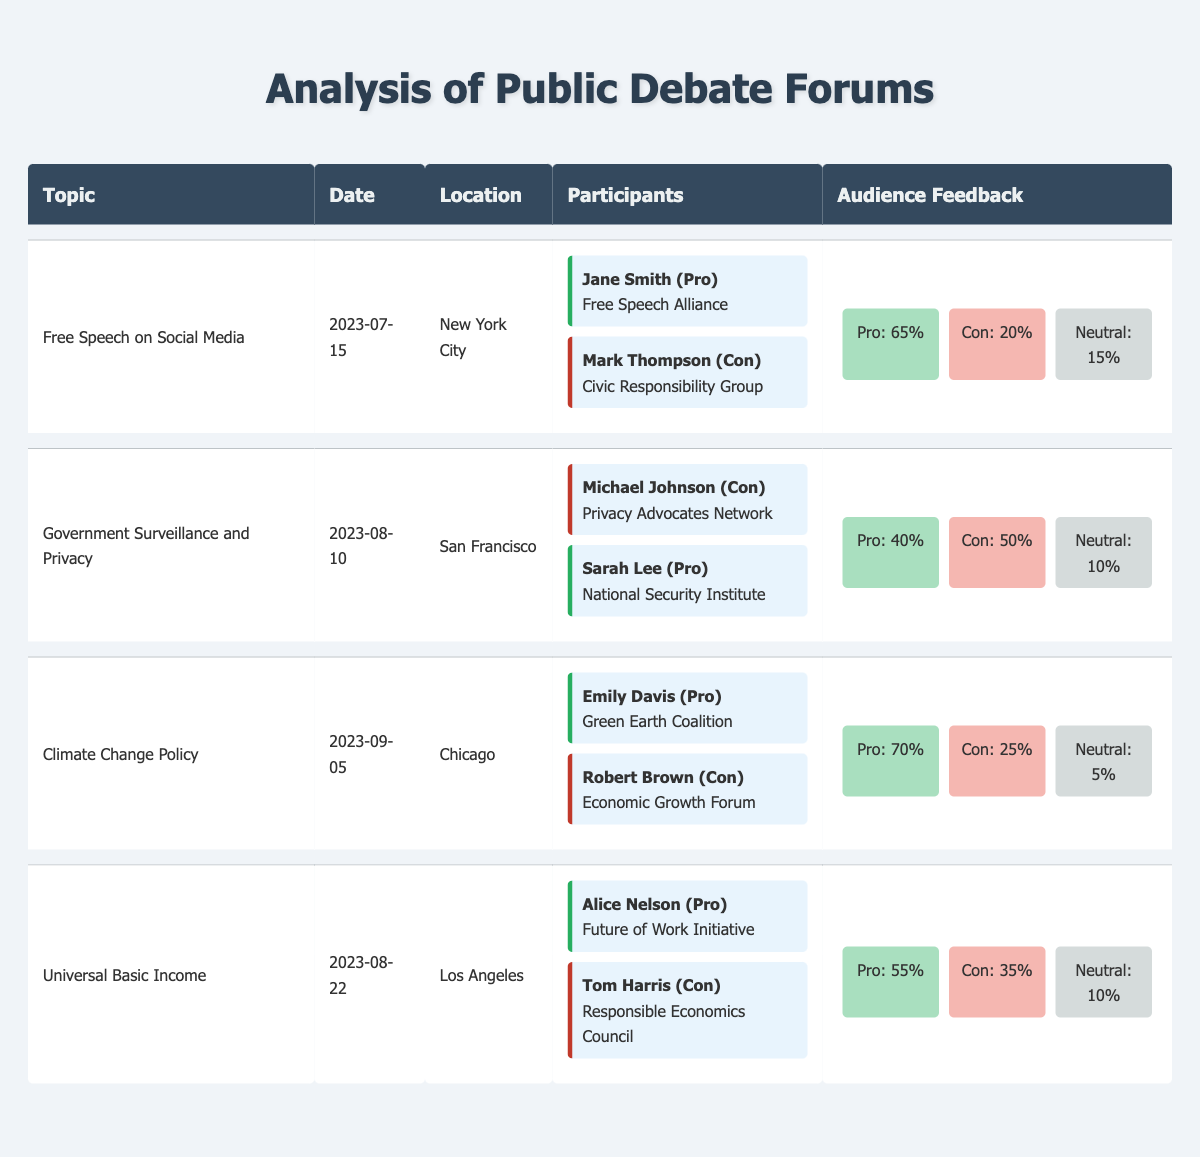What was the date of the "Free Speech on Social Media" debate? The table lists the date for each debate topic under the "Date" column. For the topic "Free Speech on Social Media," the date provided is "2023-07-15."
Answer: 2023-07-15 Who represented the "National Security Institute" in the debate on "Government Surveillance and Privacy"? In the "Participants" section of the debate on "Government Surveillance and Privacy," the participant representing the "National Security Institute" is Sarah Lee, who is listed as speaking in favor (Pro).
Answer: Sarah Lee What is the percentage of audience support for the "Pro" position in the "Climate Change Policy" debate? The audience feedback for the "Climate Change Policy" debate shows "Pro: 70%" under the audience feedback section, indicating that 70% of the audience supported the Pro position.
Answer: 70% Was there a neutral audience feedback percentage in the "Universal Basic Income" debate? Yes, the feedback section for the "Universal Basic Income" debate lists "Neutral: 10%," confirming that there was indeed a neutral feedback percentage provided for the audience.
Answer: Yes What is the average support for the "Con" positions across all debates? The support percentages for the Con positions are 20% from "Free Speech on Social Media," 50% from "Government Surveillance and Privacy," 25% from "Climate Change Policy," and 35% from "Universal Basic Income." The average is calculated as (20 + 50 + 25 + 35) / 4 = 130 / 4 = 32.5.
Answer: 32.5 How many debates had the "Pro" position supporting percentages greater than 60%? In reviewing the audience feedback, only the debates on "Free Speech on Social Media" (65%) and "Climate Change Policy" (70%) have support percentages greater than 60%. Therefore, there are 2 debates that meet this criterion.
Answer: 2 Which debate had the highest percentage of audience support for the "Con" position? The audience feedback for each debate shows that the highest "Con" percentage is from "Government Surveillance and Privacy," with 50% support for the Con position.
Answer: Government Surveillance and Privacy What is the total audience feedback percentage for the "Pro" positions across all debates? The audience feedback for the Pro positions includes 65% (Free Speech), 40% (Government Surveillance), 70% (Climate Change), and 55% (Universal Basic Income). Summing these gives 65 + 40 + 70 + 55 = 230%.
Answer: 230% 